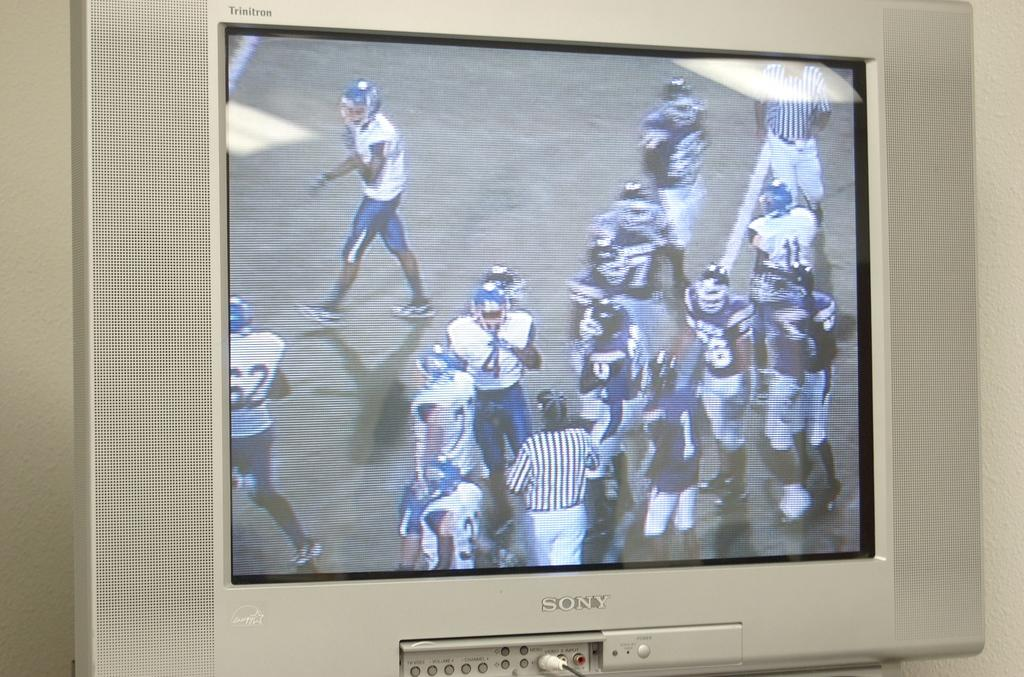<image>
Render a clear and concise summary of the photo. A sony branded Television is displaying a football game on it. 